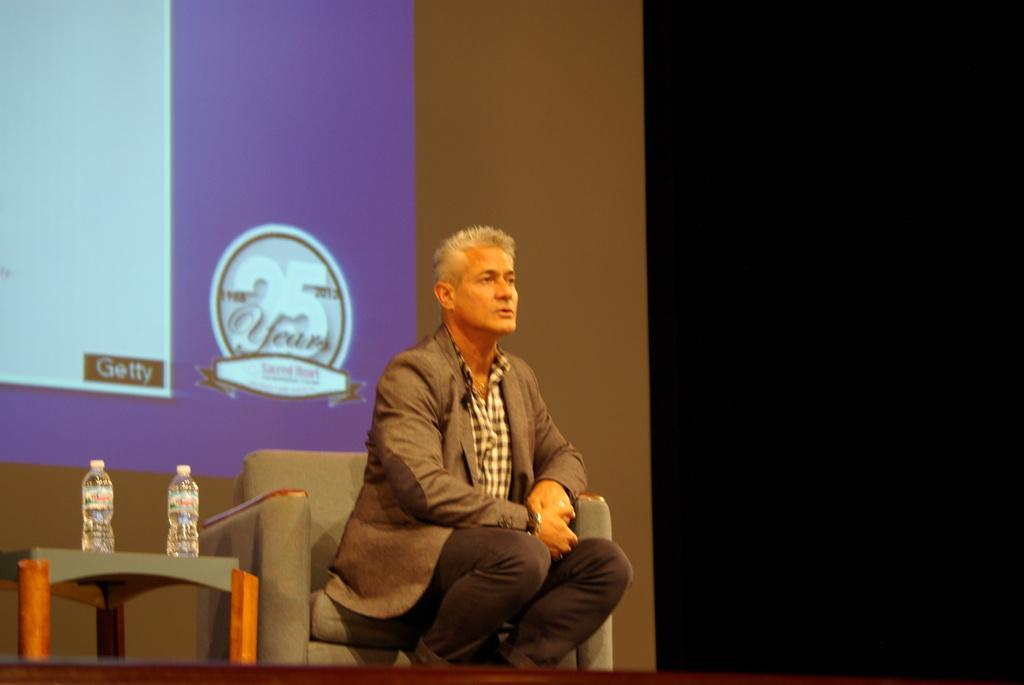Can you describe this image briefly? In this image we can see a man is sitting on the sofa. He is wearing grey color coat with shirt and pant. Left side of the image we can see one table. On table, two bottles are there. Background of the image big screen is there. 